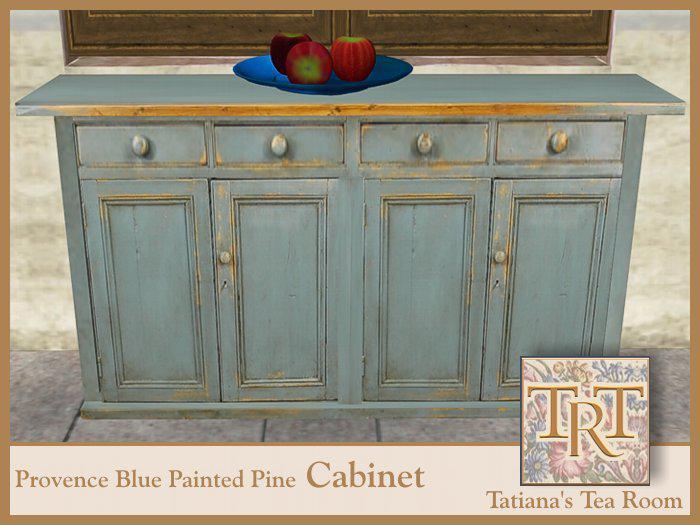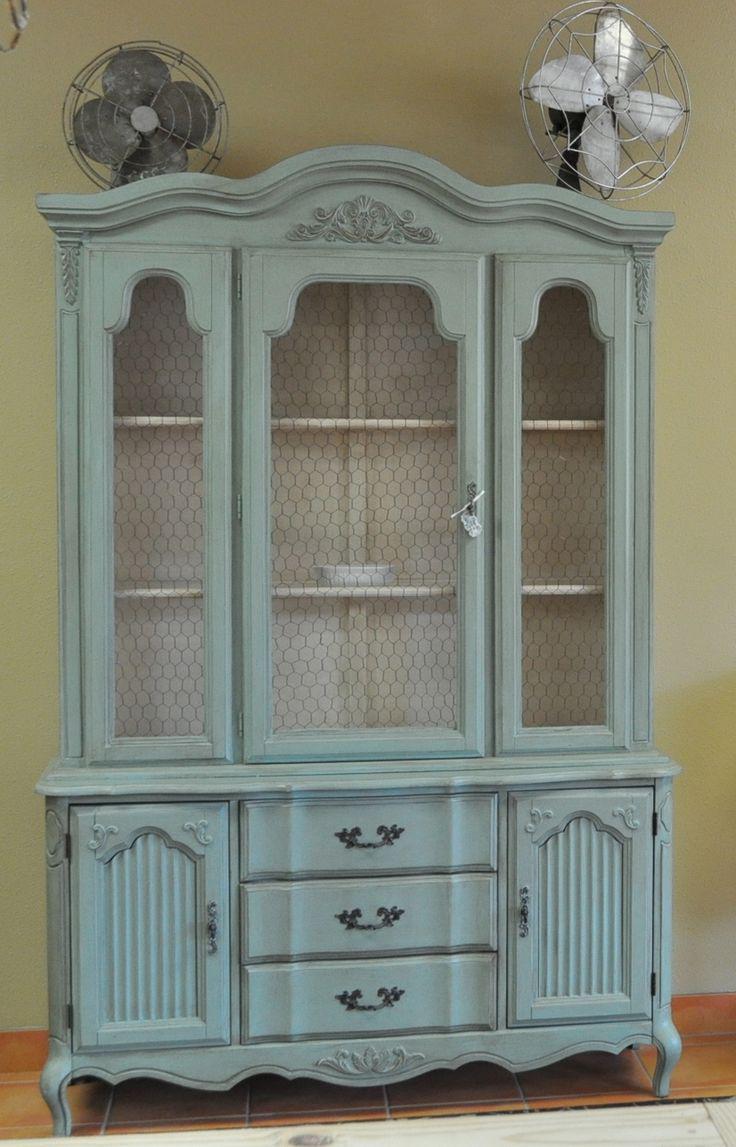The first image is the image on the left, the second image is the image on the right. Given the left and right images, does the statement "One cabinet has a curved top with a fleur-de-lis design, and scrollwork at the footed base." hold true? Answer yes or no. Yes. The first image is the image on the left, the second image is the image on the right. For the images displayed, is the sentence "A blue hutch in one image has four glass doors and four lower panel doors, and is wider than a white hutch with glass doors in the second image." factually correct? Answer yes or no. No. 